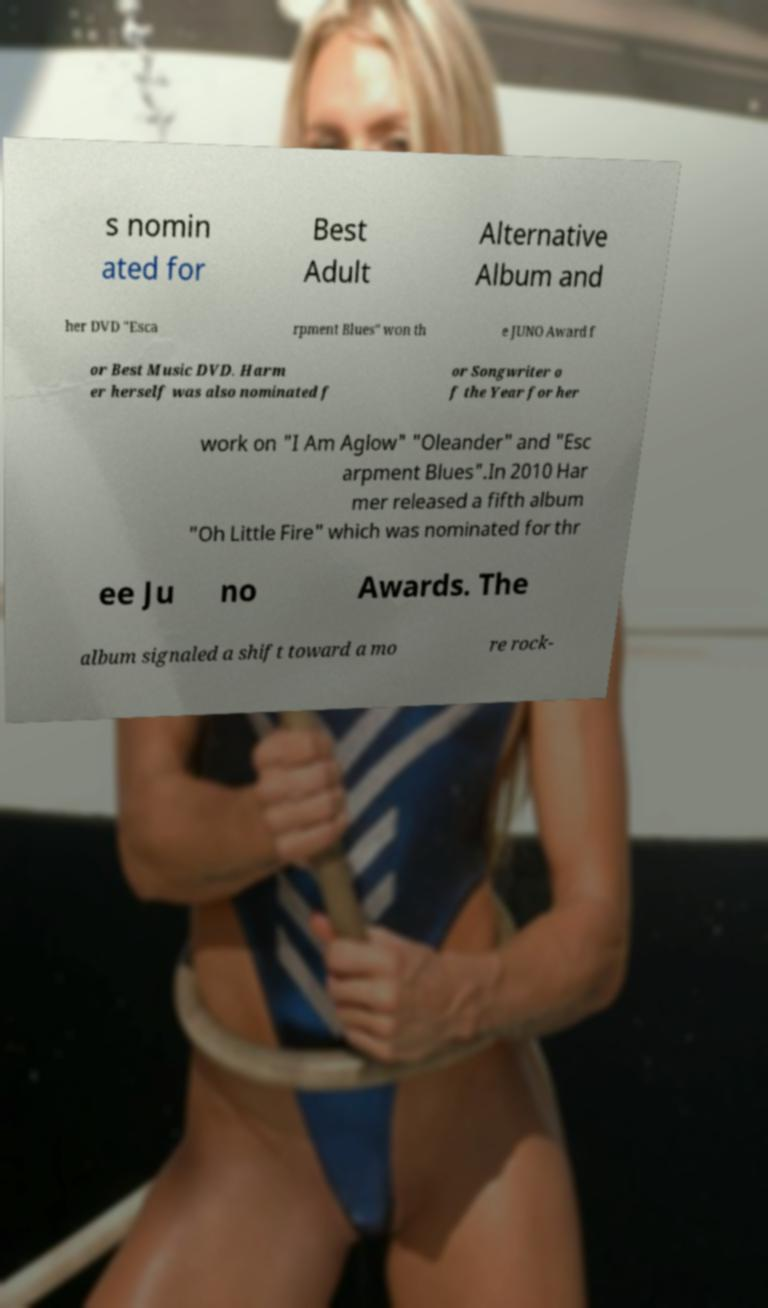What messages or text are displayed in this image? I need them in a readable, typed format. s nomin ated for Best Adult Alternative Album and her DVD "Esca rpment Blues" won th e JUNO Award f or Best Music DVD. Harm er herself was also nominated f or Songwriter o f the Year for her work on "I Am Aglow" "Oleander" and "Esc arpment Blues".In 2010 Har mer released a fifth album "Oh Little Fire" which was nominated for thr ee Ju no Awards. The album signaled a shift toward a mo re rock- 